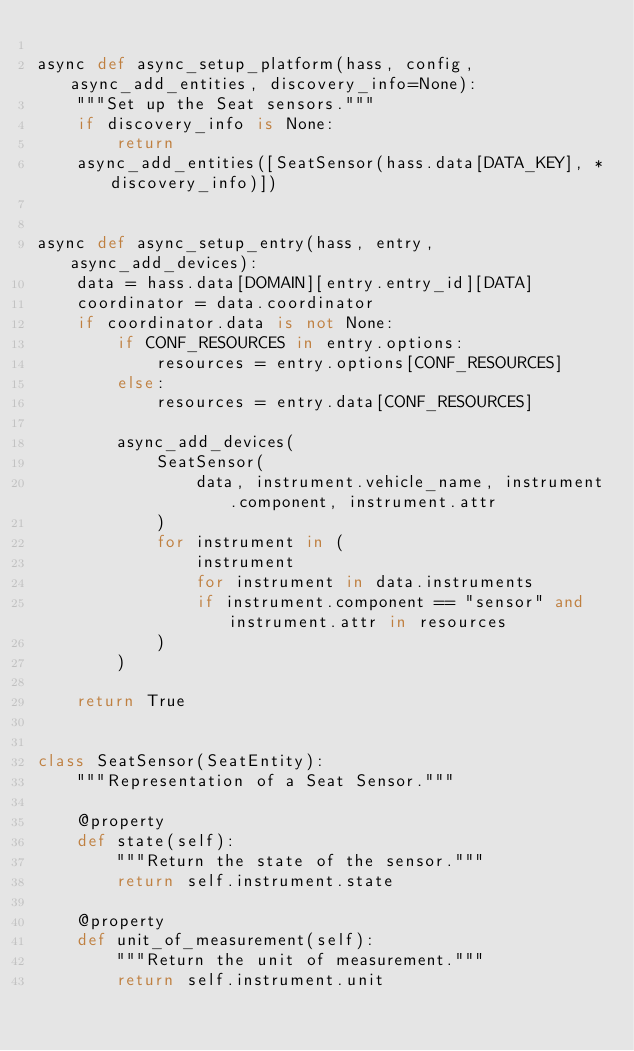Convert code to text. <code><loc_0><loc_0><loc_500><loc_500><_Python_>
async def async_setup_platform(hass, config, async_add_entities, discovery_info=None):
    """Set up the Seat sensors."""
    if discovery_info is None:
        return
    async_add_entities([SeatSensor(hass.data[DATA_KEY], *discovery_info)])


async def async_setup_entry(hass, entry, async_add_devices):
    data = hass.data[DOMAIN][entry.entry_id][DATA]
    coordinator = data.coordinator
    if coordinator.data is not None:
        if CONF_RESOURCES in entry.options:
            resources = entry.options[CONF_RESOURCES]
        else:
            resources = entry.data[CONF_RESOURCES]

        async_add_devices(
            SeatSensor(
                data, instrument.vehicle_name, instrument.component, instrument.attr
            )
            for instrument in (
                instrument
                for instrument in data.instruments
                if instrument.component == "sensor" and instrument.attr in resources
            )
        )

    return True


class SeatSensor(SeatEntity):
    """Representation of a Seat Sensor."""

    @property
    def state(self):
        """Return the state of the sensor."""
        return self.instrument.state

    @property
    def unit_of_measurement(self):
        """Return the unit of measurement."""
        return self.instrument.unit
</code> 